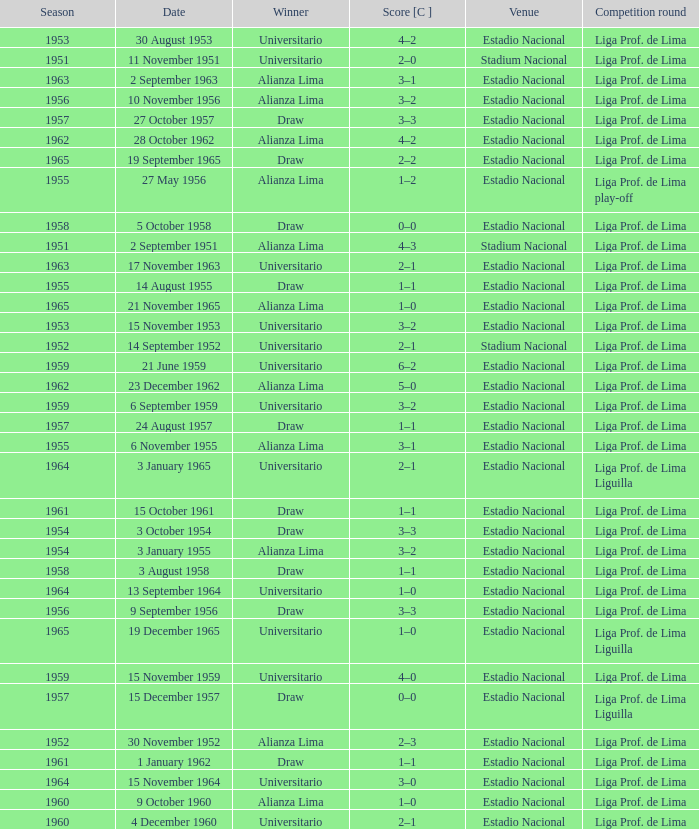What is the score of the event that Alianza Lima won in 1965? 1–0. 